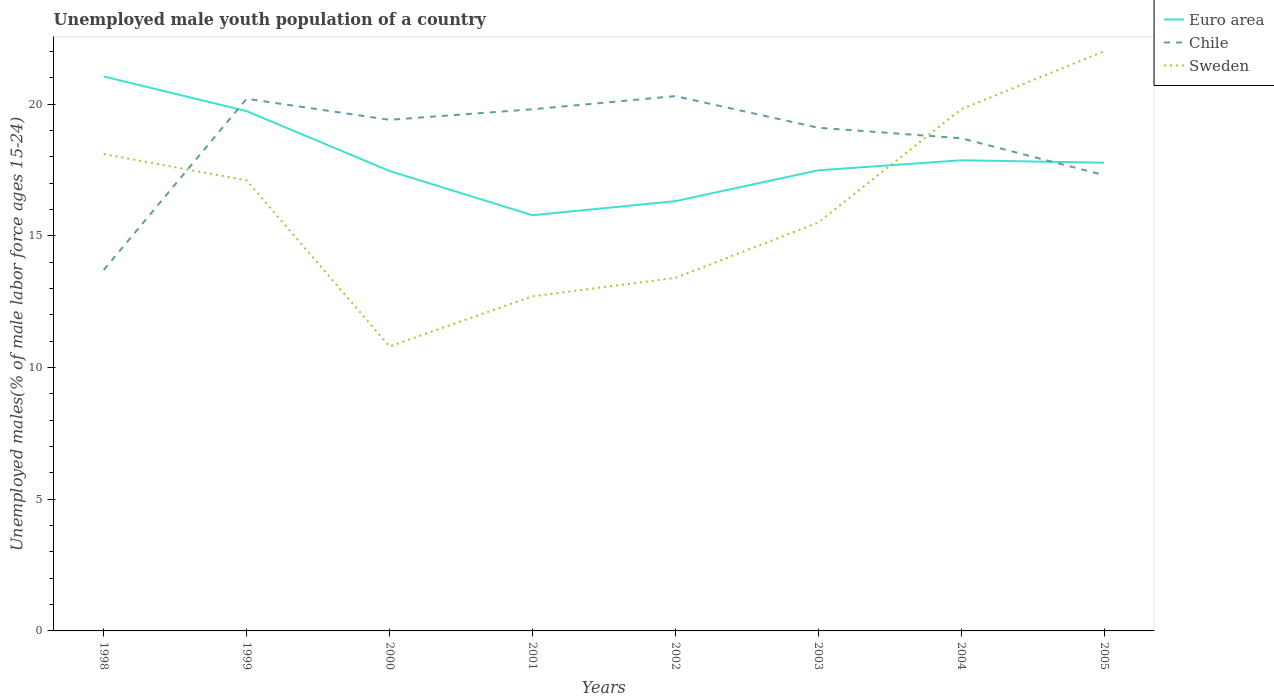How many different coloured lines are there?
Keep it short and to the point. 3. Across all years, what is the maximum percentage of unemployed male youth population in Euro area?
Offer a very short reply. 15.78. In which year was the percentage of unemployed male youth population in Sweden maximum?
Ensure brevity in your answer.  2000. What is the total percentage of unemployed male youth population in Chile in the graph?
Make the answer very short. 1.5. What is the difference between the highest and the second highest percentage of unemployed male youth population in Euro area?
Your answer should be compact. 5.27. What is the difference between the highest and the lowest percentage of unemployed male youth population in Chile?
Give a very brief answer. 6. Is the percentage of unemployed male youth population in Sweden strictly greater than the percentage of unemployed male youth population in Chile over the years?
Provide a succinct answer. No. How many years are there in the graph?
Give a very brief answer. 8. What is the difference between two consecutive major ticks on the Y-axis?
Offer a terse response. 5. Are the values on the major ticks of Y-axis written in scientific E-notation?
Give a very brief answer. No. Does the graph contain any zero values?
Your answer should be very brief. No. Does the graph contain grids?
Offer a terse response. No. Where does the legend appear in the graph?
Give a very brief answer. Top right. How are the legend labels stacked?
Provide a short and direct response. Vertical. What is the title of the graph?
Give a very brief answer. Unemployed male youth population of a country. What is the label or title of the Y-axis?
Offer a terse response. Unemployed males(% of male labor force ages 15-24). What is the Unemployed males(% of male labor force ages 15-24) of Euro area in 1998?
Your answer should be very brief. 21.05. What is the Unemployed males(% of male labor force ages 15-24) in Chile in 1998?
Keep it short and to the point. 13.7. What is the Unemployed males(% of male labor force ages 15-24) in Sweden in 1998?
Keep it short and to the point. 18.1. What is the Unemployed males(% of male labor force ages 15-24) of Euro area in 1999?
Offer a very short reply. 19.73. What is the Unemployed males(% of male labor force ages 15-24) in Chile in 1999?
Ensure brevity in your answer.  20.2. What is the Unemployed males(% of male labor force ages 15-24) of Sweden in 1999?
Give a very brief answer. 17.1. What is the Unemployed males(% of male labor force ages 15-24) in Euro area in 2000?
Offer a very short reply. 17.46. What is the Unemployed males(% of male labor force ages 15-24) of Chile in 2000?
Give a very brief answer. 19.4. What is the Unemployed males(% of male labor force ages 15-24) in Sweden in 2000?
Provide a short and direct response. 10.8. What is the Unemployed males(% of male labor force ages 15-24) of Euro area in 2001?
Offer a very short reply. 15.78. What is the Unemployed males(% of male labor force ages 15-24) in Chile in 2001?
Provide a succinct answer. 19.8. What is the Unemployed males(% of male labor force ages 15-24) in Sweden in 2001?
Offer a terse response. 12.7. What is the Unemployed males(% of male labor force ages 15-24) of Euro area in 2002?
Offer a terse response. 16.31. What is the Unemployed males(% of male labor force ages 15-24) of Chile in 2002?
Make the answer very short. 20.3. What is the Unemployed males(% of male labor force ages 15-24) in Sweden in 2002?
Give a very brief answer. 13.4. What is the Unemployed males(% of male labor force ages 15-24) in Euro area in 2003?
Offer a very short reply. 17.48. What is the Unemployed males(% of male labor force ages 15-24) of Chile in 2003?
Provide a succinct answer. 19.1. What is the Unemployed males(% of male labor force ages 15-24) in Euro area in 2004?
Provide a short and direct response. 17.86. What is the Unemployed males(% of male labor force ages 15-24) of Chile in 2004?
Keep it short and to the point. 18.7. What is the Unemployed males(% of male labor force ages 15-24) in Sweden in 2004?
Provide a succinct answer. 19.8. What is the Unemployed males(% of male labor force ages 15-24) of Euro area in 2005?
Keep it short and to the point. 17.77. What is the Unemployed males(% of male labor force ages 15-24) in Chile in 2005?
Make the answer very short. 17.3. Across all years, what is the maximum Unemployed males(% of male labor force ages 15-24) of Euro area?
Your answer should be very brief. 21.05. Across all years, what is the maximum Unemployed males(% of male labor force ages 15-24) of Chile?
Provide a short and direct response. 20.3. Across all years, what is the minimum Unemployed males(% of male labor force ages 15-24) of Euro area?
Give a very brief answer. 15.78. Across all years, what is the minimum Unemployed males(% of male labor force ages 15-24) in Chile?
Provide a short and direct response. 13.7. Across all years, what is the minimum Unemployed males(% of male labor force ages 15-24) of Sweden?
Ensure brevity in your answer.  10.8. What is the total Unemployed males(% of male labor force ages 15-24) in Euro area in the graph?
Provide a succinct answer. 143.45. What is the total Unemployed males(% of male labor force ages 15-24) in Chile in the graph?
Your answer should be compact. 148.5. What is the total Unemployed males(% of male labor force ages 15-24) in Sweden in the graph?
Give a very brief answer. 129.4. What is the difference between the Unemployed males(% of male labor force ages 15-24) in Euro area in 1998 and that in 1999?
Your answer should be compact. 1.31. What is the difference between the Unemployed males(% of male labor force ages 15-24) of Euro area in 1998 and that in 2000?
Provide a short and direct response. 3.59. What is the difference between the Unemployed males(% of male labor force ages 15-24) of Euro area in 1998 and that in 2001?
Ensure brevity in your answer.  5.27. What is the difference between the Unemployed males(% of male labor force ages 15-24) in Chile in 1998 and that in 2001?
Your answer should be very brief. -6.1. What is the difference between the Unemployed males(% of male labor force ages 15-24) in Sweden in 1998 and that in 2001?
Give a very brief answer. 5.4. What is the difference between the Unemployed males(% of male labor force ages 15-24) in Euro area in 1998 and that in 2002?
Offer a terse response. 4.73. What is the difference between the Unemployed males(% of male labor force ages 15-24) of Euro area in 1998 and that in 2003?
Provide a short and direct response. 3.56. What is the difference between the Unemployed males(% of male labor force ages 15-24) of Sweden in 1998 and that in 2003?
Ensure brevity in your answer.  2.6. What is the difference between the Unemployed males(% of male labor force ages 15-24) of Euro area in 1998 and that in 2004?
Your response must be concise. 3.18. What is the difference between the Unemployed males(% of male labor force ages 15-24) in Sweden in 1998 and that in 2004?
Your response must be concise. -1.7. What is the difference between the Unemployed males(% of male labor force ages 15-24) of Euro area in 1998 and that in 2005?
Make the answer very short. 3.27. What is the difference between the Unemployed males(% of male labor force ages 15-24) in Chile in 1998 and that in 2005?
Offer a terse response. -3.6. What is the difference between the Unemployed males(% of male labor force ages 15-24) in Euro area in 1999 and that in 2000?
Ensure brevity in your answer.  2.27. What is the difference between the Unemployed males(% of male labor force ages 15-24) in Euro area in 1999 and that in 2001?
Keep it short and to the point. 3.95. What is the difference between the Unemployed males(% of male labor force ages 15-24) of Sweden in 1999 and that in 2001?
Make the answer very short. 4.4. What is the difference between the Unemployed males(% of male labor force ages 15-24) in Euro area in 1999 and that in 2002?
Provide a short and direct response. 3.42. What is the difference between the Unemployed males(% of male labor force ages 15-24) of Chile in 1999 and that in 2002?
Provide a short and direct response. -0.1. What is the difference between the Unemployed males(% of male labor force ages 15-24) of Sweden in 1999 and that in 2002?
Your answer should be compact. 3.7. What is the difference between the Unemployed males(% of male labor force ages 15-24) of Euro area in 1999 and that in 2003?
Your response must be concise. 2.25. What is the difference between the Unemployed males(% of male labor force ages 15-24) of Chile in 1999 and that in 2003?
Ensure brevity in your answer.  1.1. What is the difference between the Unemployed males(% of male labor force ages 15-24) of Sweden in 1999 and that in 2003?
Offer a terse response. 1.6. What is the difference between the Unemployed males(% of male labor force ages 15-24) in Euro area in 1999 and that in 2004?
Your answer should be compact. 1.87. What is the difference between the Unemployed males(% of male labor force ages 15-24) in Sweden in 1999 and that in 2004?
Offer a very short reply. -2.7. What is the difference between the Unemployed males(% of male labor force ages 15-24) in Euro area in 1999 and that in 2005?
Offer a very short reply. 1.96. What is the difference between the Unemployed males(% of male labor force ages 15-24) in Sweden in 1999 and that in 2005?
Provide a succinct answer. -4.9. What is the difference between the Unemployed males(% of male labor force ages 15-24) in Euro area in 2000 and that in 2001?
Provide a short and direct response. 1.68. What is the difference between the Unemployed males(% of male labor force ages 15-24) in Chile in 2000 and that in 2001?
Provide a succinct answer. -0.4. What is the difference between the Unemployed males(% of male labor force ages 15-24) of Euro area in 2000 and that in 2002?
Provide a succinct answer. 1.15. What is the difference between the Unemployed males(% of male labor force ages 15-24) in Sweden in 2000 and that in 2002?
Your response must be concise. -2.6. What is the difference between the Unemployed males(% of male labor force ages 15-24) in Euro area in 2000 and that in 2003?
Ensure brevity in your answer.  -0.03. What is the difference between the Unemployed males(% of male labor force ages 15-24) in Sweden in 2000 and that in 2003?
Provide a succinct answer. -4.7. What is the difference between the Unemployed males(% of male labor force ages 15-24) of Euro area in 2000 and that in 2004?
Ensure brevity in your answer.  -0.41. What is the difference between the Unemployed males(% of male labor force ages 15-24) of Euro area in 2000 and that in 2005?
Your response must be concise. -0.31. What is the difference between the Unemployed males(% of male labor force ages 15-24) in Euro area in 2001 and that in 2002?
Make the answer very short. -0.53. What is the difference between the Unemployed males(% of male labor force ages 15-24) of Sweden in 2001 and that in 2002?
Offer a very short reply. -0.7. What is the difference between the Unemployed males(% of male labor force ages 15-24) in Euro area in 2001 and that in 2003?
Provide a short and direct response. -1.7. What is the difference between the Unemployed males(% of male labor force ages 15-24) in Euro area in 2001 and that in 2004?
Your answer should be very brief. -2.09. What is the difference between the Unemployed males(% of male labor force ages 15-24) in Chile in 2001 and that in 2004?
Make the answer very short. 1.1. What is the difference between the Unemployed males(% of male labor force ages 15-24) in Euro area in 2001 and that in 2005?
Provide a succinct answer. -1.99. What is the difference between the Unemployed males(% of male labor force ages 15-24) of Sweden in 2001 and that in 2005?
Offer a terse response. -9.3. What is the difference between the Unemployed males(% of male labor force ages 15-24) in Euro area in 2002 and that in 2003?
Offer a very short reply. -1.17. What is the difference between the Unemployed males(% of male labor force ages 15-24) of Sweden in 2002 and that in 2003?
Your answer should be compact. -2.1. What is the difference between the Unemployed males(% of male labor force ages 15-24) in Euro area in 2002 and that in 2004?
Provide a short and direct response. -1.55. What is the difference between the Unemployed males(% of male labor force ages 15-24) in Euro area in 2002 and that in 2005?
Provide a short and direct response. -1.46. What is the difference between the Unemployed males(% of male labor force ages 15-24) of Sweden in 2002 and that in 2005?
Ensure brevity in your answer.  -8.6. What is the difference between the Unemployed males(% of male labor force ages 15-24) of Euro area in 2003 and that in 2004?
Provide a short and direct response. -0.38. What is the difference between the Unemployed males(% of male labor force ages 15-24) in Euro area in 2003 and that in 2005?
Provide a short and direct response. -0.29. What is the difference between the Unemployed males(% of male labor force ages 15-24) of Euro area in 2004 and that in 2005?
Offer a very short reply. 0.09. What is the difference between the Unemployed males(% of male labor force ages 15-24) in Chile in 2004 and that in 2005?
Offer a terse response. 1.4. What is the difference between the Unemployed males(% of male labor force ages 15-24) of Euro area in 1998 and the Unemployed males(% of male labor force ages 15-24) of Chile in 1999?
Your answer should be very brief. 0.85. What is the difference between the Unemployed males(% of male labor force ages 15-24) in Euro area in 1998 and the Unemployed males(% of male labor force ages 15-24) in Sweden in 1999?
Offer a very short reply. 3.95. What is the difference between the Unemployed males(% of male labor force ages 15-24) of Euro area in 1998 and the Unemployed males(% of male labor force ages 15-24) of Chile in 2000?
Provide a short and direct response. 1.65. What is the difference between the Unemployed males(% of male labor force ages 15-24) in Euro area in 1998 and the Unemployed males(% of male labor force ages 15-24) in Sweden in 2000?
Your response must be concise. 10.25. What is the difference between the Unemployed males(% of male labor force ages 15-24) in Euro area in 1998 and the Unemployed males(% of male labor force ages 15-24) in Chile in 2001?
Provide a short and direct response. 1.25. What is the difference between the Unemployed males(% of male labor force ages 15-24) in Euro area in 1998 and the Unemployed males(% of male labor force ages 15-24) in Sweden in 2001?
Your response must be concise. 8.35. What is the difference between the Unemployed males(% of male labor force ages 15-24) in Euro area in 1998 and the Unemployed males(% of male labor force ages 15-24) in Chile in 2002?
Your answer should be very brief. 0.75. What is the difference between the Unemployed males(% of male labor force ages 15-24) in Euro area in 1998 and the Unemployed males(% of male labor force ages 15-24) in Sweden in 2002?
Ensure brevity in your answer.  7.65. What is the difference between the Unemployed males(% of male labor force ages 15-24) of Euro area in 1998 and the Unemployed males(% of male labor force ages 15-24) of Chile in 2003?
Your response must be concise. 1.95. What is the difference between the Unemployed males(% of male labor force ages 15-24) in Euro area in 1998 and the Unemployed males(% of male labor force ages 15-24) in Sweden in 2003?
Your answer should be very brief. 5.55. What is the difference between the Unemployed males(% of male labor force ages 15-24) in Chile in 1998 and the Unemployed males(% of male labor force ages 15-24) in Sweden in 2003?
Provide a succinct answer. -1.8. What is the difference between the Unemployed males(% of male labor force ages 15-24) of Euro area in 1998 and the Unemployed males(% of male labor force ages 15-24) of Chile in 2004?
Provide a short and direct response. 2.35. What is the difference between the Unemployed males(% of male labor force ages 15-24) in Euro area in 1998 and the Unemployed males(% of male labor force ages 15-24) in Sweden in 2004?
Keep it short and to the point. 1.25. What is the difference between the Unemployed males(% of male labor force ages 15-24) in Chile in 1998 and the Unemployed males(% of male labor force ages 15-24) in Sweden in 2004?
Ensure brevity in your answer.  -6.1. What is the difference between the Unemployed males(% of male labor force ages 15-24) of Euro area in 1998 and the Unemployed males(% of male labor force ages 15-24) of Chile in 2005?
Make the answer very short. 3.75. What is the difference between the Unemployed males(% of male labor force ages 15-24) in Euro area in 1998 and the Unemployed males(% of male labor force ages 15-24) in Sweden in 2005?
Provide a short and direct response. -0.95. What is the difference between the Unemployed males(% of male labor force ages 15-24) of Euro area in 1999 and the Unemployed males(% of male labor force ages 15-24) of Chile in 2000?
Your answer should be compact. 0.33. What is the difference between the Unemployed males(% of male labor force ages 15-24) in Euro area in 1999 and the Unemployed males(% of male labor force ages 15-24) in Sweden in 2000?
Your answer should be very brief. 8.93. What is the difference between the Unemployed males(% of male labor force ages 15-24) in Chile in 1999 and the Unemployed males(% of male labor force ages 15-24) in Sweden in 2000?
Make the answer very short. 9.4. What is the difference between the Unemployed males(% of male labor force ages 15-24) of Euro area in 1999 and the Unemployed males(% of male labor force ages 15-24) of Chile in 2001?
Provide a succinct answer. -0.07. What is the difference between the Unemployed males(% of male labor force ages 15-24) of Euro area in 1999 and the Unemployed males(% of male labor force ages 15-24) of Sweden in 2001?
Provide a succinct answer. 7.03. What is the difference between the Unemployed males(% of male labor force ages 15-24) of Euro area in 1999 and the Unemployed males(% of male labor force ages 15-24) of Chile in 2002?
Offer a terse response. -0.57. What is the difference between the Unemployed males(% of male labor force ages 15-24) of Euro area in 1999 and the Unemployed males(% of male labor force ages 15-24) of Sweden in 2002?
Offer a terse response. 6.33. What is the difference between the Unemployed males(% of male labor force ages 15-24) in Euro area in 1999 and the Unemployed males(% of male labor force ages 15-24) in Chile in 2003?
Your answer should be compact. 0.63. What is the difference between the Unemployed males(% of male labor force ages 15-24) in Euro area in 1999 and the Unemployed males(% of male labor force ages 15-24) in Sweden in 2003?
Offer a terse response. 4.23. What is the difference between the Unemployed males(% of male labor force ages 15-24) of Chile in 1999 and the Unemployed males(% of male labor force ages 15-24) of Sweden in 2003?
Make the answer very short. 4.7. What is the difference between the Unemployed males(% of male labor force ages 15-24) in Euro area in 1999 and the Unemployed males(% of male labor force ages 15-24) in Chile in 2004?
Make the answer very short. 1.03. What is the difference between the Unemployed males(% of male labor force ages 15-24) of Euro area in 1999 and the Unemployed males(% of male labor force ages 15-24) of Sweden in 2004?
Keep it short and to the point. -0.07. What is the difference between the Unemployed males(% of male labor force ages 15-24) of Euro area in 1999 and the Unemployed males(% of male labor force ages 15-24) of Chile in 2005?
Your response must be concise. 2.43. What is the difference between the Unemployed males(% of male labor force ages 15-24) of Euro area in 1999 and the Unemployed males(% of male labor force ages 15-24) of Sweden in 2005?
Your response must be concise. -2.27. What is the difference between the Unemployed males(% of male labor force ages 15-24) in Chile in 1999 and the Unemployed males(% of male labor force ages 15-24) in Sweden in 2005?
Make the answer very short. -1.8. What is the difference between the Unemployed males(% of male labor force ages 15-24) of Euro area in 2000 and the Unemployed males(% of male labor force ages 15-24) of Chile in 2001?
Your answer should be very brief. -2.34. What is the difference between the Unemployed males(% of male labor force ages 15-24) in Euro area in 2000 and the Unemployed males(% of male labor force ages 15-24) in Sweden in 2001?
Give a very brief answer. 4.76. What is the difference between the Unemployed males(% of male labor force ages 15-24) of Euro area in 2000 and the Unemployed males(% of male labor force ages 15-24) of Chile in 2002?
Provide a succinct answer. -2.84. What is the difference between the Unemployed males(% of male labor force ages 15-24) in Euro area in 2000 and the Unemployed males(% of male labor force ages 15-24) in Sweden in 2002?
Make the answer very short. 4.06. What is the difference between the Unemployed males(% of male labor force ages 15-24) of Chile in 2000 and the Unemployed males(% of male labor force ages 15-24) of Sweden in 2002?
Your answer should be compact. 6. What is the difference between the Unemployed males(% of male labor force ages 15-24) of Euro area in 2000 and the Unemployed males(% of male labor force ages 15-24) of Chile in 2003?
Give a very brief answer. -1.64. What is the difference between the Unemployed males(% of male labor force ages 15-24) of Euro area in 2000 and the Unemployed males(% of male labor force ages 15-24) of Sweden in 2003?
Give a very brief answer. 1.96. What is the difference between the Unemployed males(% of male labor force ages 15-24) of Euro area in 2000 and the Unemployed males(% of male labor force ages 15-24) of Chile in 2004?
Give a very brief answer. -1.24. What is the difference between the Unemployed males(% of male labor force ages 15-24) of Euro area in 2000 and the Unemployed males(% of male labor force ages 15-24) of Sweden in 2004?
Your response must be concise. -2.34. What is the difference between the Unemployed males(% of male labor force ages 15-24) in Chile in 2000 and the Unemployed males(% of male labor force ages 15-24) in Sweden in 2004?
Provide a succinct answer. -0.4. What is the difference between the Unemployed males(% of male labor force ages 15-24) in Euro area in 2000 and the Unemployed males(% of male labor force ages 15-24) in Chile in 2005?
Offer a terse response. 0.16. What is the difference between the Unemployed males(% of male labor force ages 15-24) of Euro area in 2000 and the Unemployed males(% of male labor force ages 15-24) of Sweden in 2005?
Ensure brevity in your answer.  -4.54. What is the difference between the Unemployed males(% of male labor force ages 15-24) in Euro area in 2001 and the Unemployed males(% of male labor force ages 15-24) in Chile in 2002?
Make the answer very short. -4.52. What is the difference between the Unemployed males(% of male labor force ages 15-24) in Euro area in 2001 and the Unemployed males(% of male labor force ages 15-24) in Sweden in 2002?
Provide a short and direct response. 2.38. What is the difference between the Unemployed males(% of male labor force ages 15-24) in Chile in 2001 and the Unemployed males(% of male labor force ages 15-24) in Sweden in 2002?
Offer a terse response. 6.4. What is the difference between the Unemployed males(% of male labor force ages 15-24) in Euro area in 2001 and the Unemployed males(% of male labor force ages 15-24) in Chile in 2003?
Your answer should be very brief. -3.32. What is the difference between the Unemployed males(% of male labor force ages 15-24) in Euro area in 2001 and the Unemployed males(% of male labor force ages 15-24) in Sweden in 2003?
Make the answer very short. 0.28. What is the difference between the Unemployed males(% of male labor force ages 15-24) of Euro area in 2001 and the Unemployed males(% of male labor force ages 15-24) of Chile in 2004?
Your response must be concise. -2.92. What is the difference between the Unemployed males(% of male labor force ages 15-24) of Euro area in 2001 and the Unemployed males(% of male labor force ages 15-24) of Sweden in 2004?
Offer a terse response. -4.02. What is the difference between the Unemployed males(% of male labor force ages 15-24) of Chile in 2001 and the Unemployed males(% of male labor force ages 15-24) of Sweden in 2004?
Give a very brief answer. 0. What is the difference between the Unemployed males(% of male labor force ages 15-24) of Euro area in 2001 and the Unemployed males(% of male labor force ages 15-24) of Chile in 2005?
Provide a succinct answer. -1.52. What is the difference between the Unemployed males(% of male labor force ages 15-24) in Euro area in 2001 and the Unemployed males(% of male labor force ages 15-24) in Sweden in 2005?
Offer a very short reply. -6.22. What is the difference between the Unemployed males(% of male labor force ages 15-24) of Chile in 2001 and the Unemployed males(% of male labor force ages 15-24) of Sweden in 2005?
Ensure brevity in your answer.  -2.2. What is the difference between the Unemployed males(% of male labor force ages 15-24) in Euro area in 2002 and the Unemployed males(% of male labor force ages 15-24) in Chile in 2003?
Offer a terse response. -2.79. What is the difference between the Unemployed males(% of male labor force ages 15-24) in Euro area in 2002 and the Unemployed males(% of male labor force ages 15-24) in Sweden in 2003?
Provide a succinct answer. 0.81. What is the difference between the Unemployed males(% of male labor force ages 15-24) of Chile in 2002 and the Unemployed males(% of male labor force ages 15-24) of Sweden in 2003?
Your response must be concise. 4.8. What is the difference between the Unemployed males(% of male labor force ages 15-24) in Euro area in 2002 and the Unemployed males(% of male labor force ages 15-24) in Chile in 2004?
Keep it short and to the point. -2.39. What is the difference between the Unemployed males(% of male labor force ages 15-24) in Euro area in 2002 and the Unemployed males(% of male labor force ages 15-24) in Sweden in 2004?
Provide a short and direct response. -3.49. What is the difference between the Unemployed males(% of male labor force ages 15-24) of Chile in 2002 and the Unemployed males(% of male labor force ages 15-24) of Sweden in 2004?
Your answer should be very brief. 0.5. What is the difference between the Unemployed males(% of male labor force ages 15-24) of Euro area in 2002 and the Unemployed males(% of male labor force ages 15-24) of Chile in 2005?
Your answer should be very brief. -0.99. What is the difference between the Unemployed males(% of male labor force ages 15-24) of Euro area in 2002 and the Unemployed males(% of male labor force ages 15-24) of Sweden in 2005?
Your answer should be very brief. -5.69. What is the difference between the Unemployed males(% of male labor force ages 15-24) of Euro area in 2003 and the Unemployed males(% of male labor force ages 15-24) of Chile in 2004?
Your response must be concise. -1.22. What is the difference between the Unemployed males(% of male labor force ages 15-24) in Euro area in 2003 and the Unemployed males(% of male labor force ages 15-24) in Sweden in 2004?
Offer a terse response. -2.32. What is the difference between the Unemployed males(% of male labor force ages 15-24) in Chile in 2003 and the Unemployed males(% of male labor force ages 15-24) in Sweden in 2004?
Offer a very short reply. -0.7. What is the difference between the Unemployed males(% of male labor force ages 15-24) of Euro area in 2003 and the Unemployed males(% of male labor force ages 15-24) of Chile in 2005?
Offer a terse response. 0.18. What is the difference between the Unemployed males(% of male labor force ages 15-24) of Euro area in 2003 and the Unemployed males(% of male labor force ages 15-24) of Sweden in 2005?
Your answer should be very brief. -4.52. What is the difference between the Unemployed males(% of male labor force ages 15-24) in Euro area in 2004 and the Unemployed males(% of male labor force ages 15-24) in Chile in 2005?
Offer a very short reply. 0.56. What is the difference between the Unemployed males(% of male labor force ages 15-24) of Euro area in 2004 and the Unemployed males(% of male labor force ages 15-24) of Sweden in 2005?
Ensure brevity in your answer.  -4.14. What is the difference between the Unemployed males(% of male labor force ages 15-24) of Chile in 2004 and the Unemployed males(% of male labor force ages 15-24) of Sweden in 2005?
Provide a succinct answer. -3.3. What is the average Unemployed males(% of male labor force ages 15-24) of Euro area per year?
Your response must be concise. 17.93. What is the average Unemployed males(% of male labor force ages 15-24) in Chile per year?
Offer a very short reply. 18.56. What is the average Unemployed males(% of male labor force ages 15-24) of Sweden per year?
Keep it short and to the point. 16.18. In the year 1998, what is the difference between the Unemployed males(% of male labor force ages 15-24) in Euro area and Unemployed males(% of male labor force ages 15-24) in Chile?
Your answer should be compact. 7.35. In the year 1998, what is the difference between the Unemployed males(% of male labor force ages 15-24) in Euro area and Unemployed males(% of male labor force ages 15-24) in Sweden?
Your answer should be compact. 2.95. In the year 1998, what is the difference between the Unemployed males(% of male labor force ages 15-24) in Chile and Unemployed males(% of male labor force ages 15-24) in Sweden?
Your response must be concise. -4.4. In the year 1999, what is the difference between the Unemployed males(% of male labor force ages 15-24) of Euro area and Unemployed males(% of male labor force ages 15-24) of Chile?
Offer a terse response. -0.47. In the year 1999, what is the difference between the Unemployed males(% of male labor force ages 15-24) of Euro area and Unemployed males(% of male labor force ages 15-24) of Sweden?
Offer a very short reply. 2.63. In the year 1999, what is the difference between the Unemployed males(% of male labor force ages 15-24) of Chile and Unemployed males(% of male labor force ages 15-24) of Sweden?
Your answer should be compact. 3.1. In the year 2000, what is the difference between the Unemployed males(% of male labor force ages 15-24) in Euro area and Unemployed males(% of male labor force ages 15-24) in Chile?
Provide a succinct answer. -1.94. In the year 2000, what is the difference between the Unemployed males(% of male labor force ages 15-24) of Euro area and Unemployed males(% of male labor force ages 15-24) of Sweden?
Your answer should be compact. 6.66. In the year 2001, what is the difference between the Unemployed males(% of male labor force ages 15-24) of Euro area and Unemployed males(% of male labor force ages 15-24) of Chile?
Offer a very short reply. -4.02. In the year 2001, what is the difference between the Unemployed males(% of male labor force ages 15-24) of Euro area and Unemployed males(% of male labor force ages 15-24) of Sweden?
Keep it short and to the point. 3.08. In the year 2002, what is the difference between the Unemployed males(% of male labor force ages 15-24) in Euro area and Unemployed males(% of male labor force ages 15-24) in Chile?
Offer a terse response. -3.99. In the year 2002, what is the difference between the Unemployed males(% of male labor force ages 15-24) in Euro area and Unemployed males(% of male labor force ages 15-24) in Sweden?
Your answer should be compact. 2.91. In the year 2003, what is the difference between the Unemployed males(% of male labor force ages 15-24) of Euro area and Unemployed males(% of male labor force ages 15-24) of Chile?
Provide a succinct answer. -1.62. In the year 2003, what is the difference between the Unemployed males(% of male labor force ages 15-24) in Euro area and Unemployed males(% of male labor force ages 15-24) in Sweden?
Offer a very short reply. 1.98. In the year 2003, what is the difference between the Unemployed males(% of male labor force ages 15-24) in Chile and Unemployed males(% of male labor force ages 15-24) in Sweden?
Ensure brevity in your answer.  3.6. In the year 2004, what is the difference between the Unemployed males(% of male labor force ages 15-24) of Euro area and Unemployed males(% of male labor force ages 15-24) of Chile?
Keep it short and to the point. -0.84. In the year 2004, what is the difference between the Unemployed males(% of male labor force ages 15-24) of Euro area and Unemployed males(% of male labor force ages 15-24) of Sweden?
Your response must be concise. -1.94. In the year 2004, what is the difference between the Unemployed males(% of male labor force ages 15-24) of Chile and Unemployed males(% of male labor force ages 15-24) of Sweden?
Your answer should be very brief. -1.1. In the year 2005, what is the difference between the Unemployed males(% of male labor force ages 15-24) of Euro area and Unemployed males(% of male labor force ages 15-24) of Chile?
Offer a terse response. 0.47. In the year 2005, what is the difference between the Unemployed males(% of male labor force ages 15-24) in Euro area and Unemployed males(% of male labor force ages 15-24) in Sweden?
Your answer should be very brief. -4.23. In the year 2005, what is the difference between the Unemployed males(% of male labor force ages 15-24) in Chile and Unemployed males(% of male labor force ages 15-24) in Sweden?
Offer a very short reply. -4.7. What is the ratio of the Unemployed males(% of male labor force ages 15-24) of Euro area in 1998 to that in 1999?
Offer a very short reply. 1.07. What is the ratio of the Unemployed males(% of male labor force ages 15-24) in Chile in 1998 to that in 1999?
Your answer should be compact. 0.68. What is the ratio of the Unemployed males(% of male labor force ages 15-24) in Sweden in 1998 to that in 1999?
Offer a very short reply. 1.06. What is the ratio of the Unemployed males(% of male labor force ages 15-24) of Euro area in 1998 to that in 2000?
Provide a short and direct response. 1.21. What is the ratio of the Unemployed males(% of male labor force ages 15-24) in Chile in 1998 to that in 2000?
Your answer should be compact. 0.71. What is the ratio of the Unemployed males(% of male labor force ages 15-24) of Sweden in 1998 to that in 2000?
Your answer should be very brief. 1.68. What is the ratio of the Unemployed males(% of male labor force ages 15-24) of Euro area in 1998 to that in 2001?
Ensure brevity in your answer.  1.33. What is the ratio of the Unemployed males(% of male labor force ages 15-24) in Chile in 1998 to that in 2001?
Provide a short and direct response. 0.69. What is the ratio of the Unemployed males(% of male labor force ages 15-24) of Sweden in 1998 to that in 2001?
Make the answer very short. 1.43. What is the ratio of the Unemployed males(% of male labor force ages 15-24) of Euro area in 1998 to that in 2002?
Your answer should be very brief. 1.29. What is the ratio of the Unemployed males(% of male labor force ages 15-24) of Chile in 1998 to that in 2002?
Offer a very short reply. 0.67. What is the ratio of the Unemployed males(% of male labor force ages 15-24) in Sweden in 1998 to that in 2002?
Your response must be concise. 1.35. What is the ratio of the Unemployed males(% of male labor force ages 15-24) of Euro area in 1998 to that in 2003?
Provide a succinct answer. 1.2. What is the ratio of the Unemployed males(% of male labor force ages 15-24) in Chile in 1998 to that in 2003?
Provide a short and direct response. 0.72. What is the ratio of the Unemployed males(% of male labor force ages 15-24) of Sweden in 1998 to that in 2003?
Keep it short and to the point. 1.17. What is the ratio of the Unemployed males(% of male labor force ages 15-24) in Euro area in 1998 to that in 2004?
Your response must be concise. 1.18. What is the ratio of the Unemployed males(% of male labor force ages 15-24) of Chile in 1998 to that in 2004?
Provide a succinct answer. 0.73. What is the ratio of the Unemployed males(% of male labor force ages 15-24) of Sweden in 1998 to that in 2004?
Keep it short and to the point. 0.91. What is the ratio of the Unemployed males(% of male labor force ages 15-24) in Euro area in 1998 to that in 2005?
Offer a very short reply. 1.18. What is the ratio of the Unemployed males(% of male labor force ages 15-24) in Chile in 1998 to that in 2005?
Your answer should be very brief. 0.79. What is the ratio of the Unemployed males(% of male labor force ages 15-24) in Sweden in 1998 to that in 2005?
Give a very brief answer. 0.82. What is the ratio of the Unemployed males(% of male labor force ages 15-24) of Euro area in 1999 to that in 2000?
Your answer should be very brief. 1.13. What is the ratio of the Unemployed males(% of male labor force ages 15-24) in Chile in 1999 to that in 2000?
Keep it short and to the point. 1.04. What is the ratio of the Unemployed males(% of male labor force ages 15-24) in Sweden in 1999 to that in 2000?
Give a very brief answer. 1.58. What is the ratio of the Unemployed males(% of male labor force ages 15-24) in Euro area in 1999 to that in 2001?
Your answer should be very brief. 1.25. What is the ratio of the Unemployed males(% of male labor force ages 15-24) in Chile in 1999 to that in 2001?
Provide a short and direct response. 1.02. What is the ratio of the Unemployed males(% of male labor force ages 15-24) in Sweden in 1999 to that in 2001?
Your response must be concise. 1.35. What is the ratio of the Unemployed males(% of male labor force ages 15-24) in Euro area in 1999 to that in 2002?
Make the answer very short. 1.21. What is the ratio of the Unemployed males(% of male labor force ages 15-24) of Chile in 1999 to that in 2002?
Make the answer very short. 1. What is the ratio of the Unemployed males(% of male labor force ages 15-24) of Sweden in 1999 to that in 2002?
Offer a very short reply. 1.28. What is the ratio of the Unemployed males(% of male labor force ages 15-24) in Euro area in 1999 to that in 2003?
Provide a succinct answer. 1.13. What is the ratio of the Unemployed males(% of male labor force ages 15-24) in Chile in 1999 to that in 2003?
Offer a very short reply. 1.06. What is the ratio of the Unemployed males(% of male labor force ages 15-24) of Sweden in 1999 to that in 2003?
Ensure brevity in your answer.  1.1. What is the ratio of the Unemployed males(% of male labor force ages 15-24) of Euro area in 1999 to that in 2004?
Offer a very short reply. 1.1. What is the ratio of the Unemployed males(% of male labor force ages 15-24) in Chile in 1999 to that in 2004?
Give a very brief answer. 1.08. What is the ratio of the Unemployed males(% of male labor force ages 15-24) in Sweden in 1999 to that in 2004?
Your response must be concise. 0.86. What is the ratio of the Unemployed males(% of male labor force ages 15-24) of Euro area in 1999 to that in 2005?
Offer a very short reply. 1.11. What is the ratio of the Unemployed males(% of male labor force ages 15-24) of Chile in 1999 to that in 2005?
Give a very brief answer. 1.17. What is the ratio of the Unemployed males(% of male labor force ages 15-24) in Sweden in 1999 to that in 2005?
Your response must be concise. 0.78. What is the ratio of the Unemployed males(% of male labor force ages 15-24) of Euro area in 2000 to that in 2001?
Keep it short and to the point. 1.11. What is the ratio of the Unemployed males(% of male labor force ages 15-24) in Chile in 2000 to that in 2001?
Offer a terse response. 0.98. What is the ratio of the Unemployed males(% of male labor force ages 15-24) in Sweden in 2000 to that in 2001?
Keep it short and to the point. 0.85. What is the ratio of the Unemployed males(% of male labor force ages 15-24) in Euro area in 2000 to that in 2002?
Provide a succinct answer. 1.07. What is the ratio of the Unemployed males(% of male labor force ages 15-24) in Chile in 2000 to that in 2002?
Give a very brief answer. 0.96. What is the ratio of the Unemployed males(% of male labor force ages 15-24) of Sweden in 2000 to that in 2002?
Give a very brief answer. 0.81. What is the ratio of the Unemployed males(% of male labor force ages 15-24) in Chile in 2000 to that in 2003?
Ensure brevity in your answer.  1.02. What is the ratio of the Unemployed males(% of male labor force ages 15-24) of Sweden in 2000 to that in 2003?
Ensure brevity in your answer.  0.7. What is the ratio of the Unemployed males(% of male labor force ages 15-24) of Euro area in 2000 to that in 2004?
Ensure brevity in your answer.  0.98. What is the ratio of the Unemployed males(% of male labor force ages 15-24) in Chile in 2000 to that in 2004?
Offer a very short reply. 1.04. What is the ratio of the Unemployed males(% of male labor force ages 15-24) of Sweden in 2000 to that in 2004?
Your answer should be compact. 0.55. What is the ratio of the Unemployed males(% of male labor force ages 15-24) of Euro area in 2000 to that in 2005?
Offer a very short reply. 0.98. What is the ratio of the Unemployed males(% of male labor force ages 15-24) in Chile in 2000 to that in 2005?
Keep it short and to the point. 1.12. What is the ratio of the Unemployed males(% of male labor force ages 15-24) in Sweden in 2000 to that in 2005?
Offer a very short reply. 0.49. What is the ratio of the Unemployed males(% of male labor force ages 15-24) in Euro area in 2001 to that in 2002?
Offer a very short reply. 0.97. What is the ratio of the Unemployed males(% of male labor force ages 15-24) in Chile in 2001 to that in 2002?
Make the answer very short. 0.98. What is the ratio of the Unemployed males(% of male labor force ages 15-24) of Sweden in 2001 to that in 2002?
Your response must be concise. 0.95. What is the ratio of the Unemployed males(% of male labor force ages 15-24) in Euro area in 2001 to that in 2003?
Make the answer very short. 0.9. What is the ratio of the Unemployed males(% of male labor force ages 15-24) in Chile in 2001 to that in 2003?
Your response must be concise. 1.04. What is the ratio of the Unemployed males(% of male labor force ages 15-24) of Sweden in 2001 to that in 2003?
Offer a terse response. 0.82. What is the ratio of the Unemployed males(% of male labor force ages 15-24) of Euro area in 2001 to that in 2004?
Your response must be concise. 0.88. What is the ratio of the Unemployed males(% of male labor force ages 15-24) of Chile in 2001 to that in 2004?
Your answer should be compact. 1.06. What is the ratio of the Unemployed males(% of male labor force ages 15-24) in Sweden in 2001 to that in 2004?
Provide a short and direct response. 0.64. What is the ratio of the Unemployed males(% of male labor force ages 15-24) in Euro area in 2001 to that in 2005?
Offer a terse response. 0.89. What is the ratio of the Unemployed males(% of male labor force ages 15-24) of Chile in 2001 to that in 2005?
Provide a succinct answer. 1.14. What is the ratio of the Unemployed males(% of male labor force ages 15-24) of Sweden in 2001 to that in 2005?
Keep it short and to the point. 0.58. What is the ratio of the Unemployed males(% of male labor force ages 15-24) in Euro area in 2002 to that in 2003?
Ensure brevity in your answer.  0.93. What is the ratio of the Unemployed males(% of male labor force ages 15-24) in Chile in 2002 to that in 2003?
Offer a terse response. 1.06. What is the ratio of the Unemployed males(% of male labor force ages 15-24) in Sweden in 2002 to that in 2003?
Your answer should be very brief. 0.86. What is the ratio of the Unemployed males(% of male labor force ages 15-24) of Euro area in 2002 to that in 2004?
Provide a short and direct response. 0.91. What is the ratio of the Unemployed males(% of male labor force ages 15-24) in Chile in 2002 to that in 2004?
Your answer should be compact. 1.09. What is the ratio of the Unemployed males(% of male labor force ages 15-24) in Sweden in 2002 to that in 2004?
Offer a very short reply. 0.68. What is the ratio of the Unemployed males(% of male labor force ages 15-24) in Euro area in 2002 to that in 2005?
Provide a short and direct response. 0.92. What is the ratio of the Unemployed males(% of male labor force ages 15-24) in Chile in 2002 to that in 2005?
Offer a very short reply. 1.17. What is the ratio of the Unemployed males(% of male labor force ages 15-24) in Sweden in 2002 to that in 2005?
Offer a very short reply. 0.61. What is the ratio of the Unemployed males(% of male labor force ages 15-24) of Euro area in 2003 to that in 2004?
Your answer should be compact. 0.98. What is the ratio of the Unemployed males(% of male labor force ages 15-24) of Chile in 2003 to that in 2004?
Provide a succinct answer. 1.02. What is the ratio of the Unemployed males(% of male labor force ages 15-24) of Sweden in 2003 to that in 2004?
Your answer should be very brief. 0.78. What is the ratio of the Unemployed males(% of male labor force ages 15-24) of Euro area in 2003 to that in 2005?
Your response must be concise. 0.98. What is the ratio of the Unemployed males(% of male labor force ages 15-24) of Chile in 2003 to that in 2005?
Your response must be concise. 1.1. What is the ratio of the Unemployed males(% of male labor force ages 15-24) in Sweden in 2003 to that in 2005?
Make the answer very short. 0.7. What is the ratio of the Unemployed males(% of male labor force ages 15-24) in Chile in 2004 to that in 2005?
Your answer should be very brief. 1.08. What is the ratio of the Unemployed males(% of male labor force ages 15-24) in Sweden in 2004 to that in 2005?
Offer a very short reply. 0.9. What is the difference between the highest and the second highest Unemployed males(% of male labor force ages 15-24) in Euro area?
Your answer should be compact. 1.31. What is the difference between the highest and the second highest Unemployed males(% of male labor force ages 15-24) in Chile?
Give a very brief answer. 0.1. What is the difference between the highest and the second highest Unemployed males(% of male labor force ages 15-24) of Sweden?
Your response must be concise. 2.2. What is the difference between the highest and the lowest Unemployed males(% of male labor force ages 15-24) in Euro area?
Offer a terse response. 5.27. What is the difference between the highest and the lowest Unemployed males(% of male labor force ages 15-24) in Sweden?
Offer a very short reply. 11.2. 